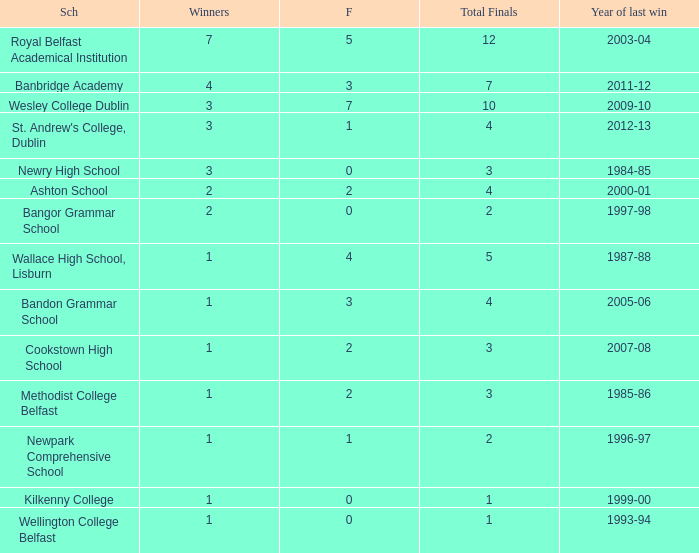How many times was banbridge academy the winner? 1.0. 